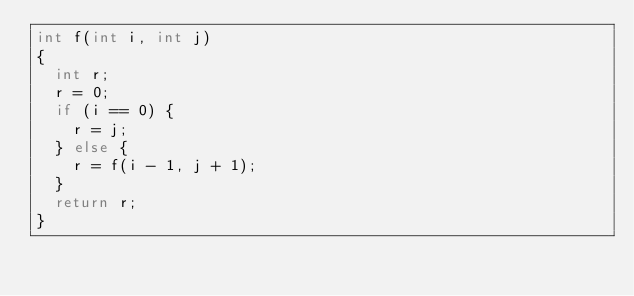Convert code to text. <code><loc_0><loc_0><loc_500><loc_500><_C_>int f(int i, int j)
{
  int r;
  r = 0;
  if (i == 0) {
    r = j;
  } else {
    r = f(i - 1, j + 1);
  }
  return r;
}
</code> 